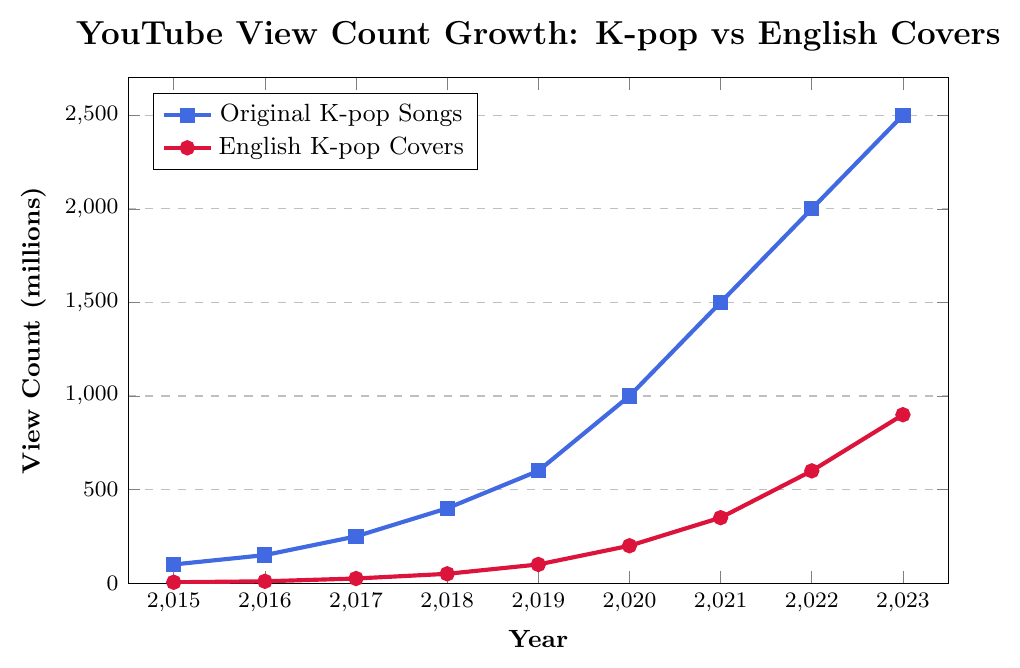What is the total view count for Original K-pop Songs in 2020 and 2023? In 2020, the view count for Original K-pop Songs is 1000 million, and in 2023, it is 2500 million. Adding these two values gives 1000 + 2500 = 3500 million.
Answer: 3500 million Which year saw the highest view count for English K-pop Covers? By examining the line chart for English K-pop Covers, the highest point is in 2023, where the view count is 900 million.
Answer: 2023 Between 2015 and 2022, which type of video saw a greater percentage increase in views: Original K-pop Songs or English K-pop Covers? For Original K-pop Songs: 
Initial views in 2015: 100 million, views in 2022: 2000 million. Percentage increase = ((2000 - 100) / 100) * 100 = 1900%.
For English K-pop Covers: 
Initial views in 2015: 5 million, views in 2022: 600 million. Percentage increase = ((600 - 5) / 5) * 100 = 11900%.
Comparing the two, English K-pop Covers saw a greater percentage increase (11900% vs 1900%).
Answer: English K-pop Covers How much did the view count for Original K-pop Songs increase from 2019 to 2021? The view count for Original K-pop Songs in 2019 is 600 million and in 2021 it is 1500 million. The increase is 1500 - 600 = 900 million.
Answer: 900 million Which year had a larger absolute increase in views for English K-pop Covers: 2020 to 2021 or 2022 to 2023? From 2020 to 2021, view counts increased from 200 million to 350 million, an increase of 350 - 200 = 150 million.
From 2022 to 2023, view counts increased from 600 million to 900 million, an increase of 900 - 600 = 300 million.
Thus, the increase from 2022 to 2023 is larger.
Answer: 2022 to 2023 In which year did the view count for English K-pop Covers first reach 100 million? Examining the chart, English K-pop Covers reached 100 million views in 2019.
Answer: 2019 What is the rate of increase in views per year for Original K-pop Songs from 2015 to 2018? From 2015 to 2018, the view count for Original K-pop Songs increased from 100 million to 400 million. The total increase is 400 - 100 = 300 million over 3 years, so the rate of increase per year is 300 / 3 = 100 million per year.
Answer: 100 million per year Which type of video had more consistent growth in view count between 2018 and 2020? Examining 2018 to 2020, Original K-pop Songs increased from 400 million to 1000 million, showing a smooth and steady rise. English K-pop Covers increased from 50 million to 200 million, also relatively consistent. When comparing the two, both types appear to have fairly consistent growth in this period.
Answer: Both types By how much did the view counts differ between Original K-pop Songs and English K-pop Covers in 2017? In 2017, the view count for Original K-pop Songs is 250 million and for English K-pop Covers it is 25 million. The difference is 250 - 25 = 225 million.
Answer: 225 million How does the increase in views of English K-pop Covers from 2015 to 2023 compare to the increase in the same period for Original K-pop Songs? From 2015 to 2023, views for Original K-pop Songs increased from 100 million to 2500 million, which is an increase of 2500 - 100 = 2400 million.
For English K-pop Covers, views increased from 5 million to 900 million, which is an increase of 900 - 5 = 895 million.
Comparing the increases, Original K-pop Songs have a larger increase of 2400 million vs 895 million for English K-pop Covers.
Answer: Original K-pop Songs 